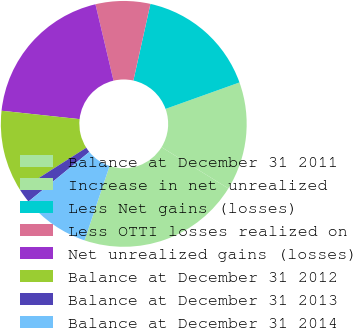Convert chart to OTSL. <chart><loc_0><loc_0><loc_500><loc_500><pie_chart><fcel>Balance at December 31 2011<fcel>Increase in net unrealized<fcel>Less Net gains (losses)<fcel>Less OTTI losses realized on<fcel>Net unrealized gains (losses)<fcel>Balance at December 31 2012<fcel>Balance at December 31 2013<fcel>Balance at December 31 2014<nl><fcel>21.37%<fcel>14.27%<fcel>16.05%<fcel>7.18%<fcel>19.6%<fcel>10.73%<fcel>1.86%<fcel>8.95%<nl></chart> 